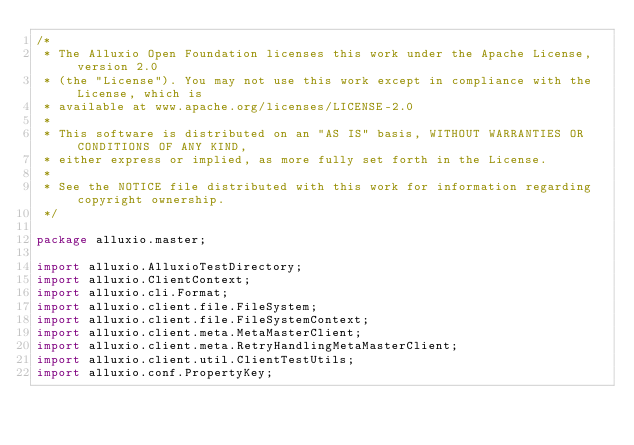<code> <loc_0><loc_0><loc_500><loc_500><_Java_>/*
 * The Alluxio Open Foundation licenses this work under the Apache License, version 2.0
 * (the "License"). You may not use this work except in compliance with the License, which is
 * available at www.apache.org/licenses/LICENSE-2.0
 *
 * This software is distributed on an "AS IS" basis, WITHOUT WARRANTIES OR CONDITIONS OF ANY KIND,
 * either express or implied, as more fully set forth in the License.
 *
 * See the NOTICE file distributed with this work for information regarding copyright ownership.
 */

package alluxio.master;

import alluxio.AlluxioTestDirectory;
import alluxio.ClientContext;
import alluxio.cli.Format;
import alluxio.client.file.FileSystem;
import alluxio.client.file.FileSystemContext;
import alluxio.client.meta.MetaMasterClient;
import alluxio.client.meta.RetryHandlingMetaMasterClient;
import alluxio.client.util.ClientTestUtils;
import alluxio.conf.PropertyKey;</code> 